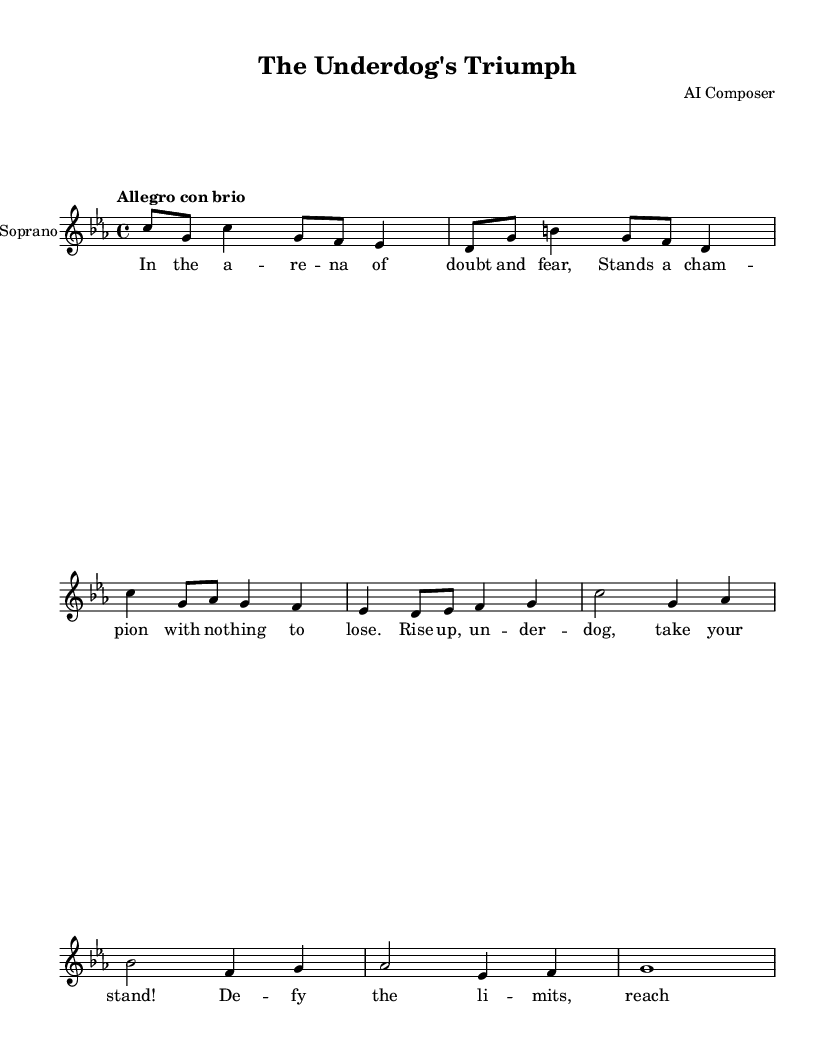What is the key signature of this music? The key signature is indicated at the beginning of the score. In this case, it shows four flats, which indicates that the piece is in C minor.
Answer: C minor What is the time signature of this music? The time signature is located after the key signature at the beginning of the score. It shows '4/4', meaning there are four beats in each measure.
Answer: 4/4 What is the tempo marking of this piece? The tempo marking is written above the music at the start. It states "Allegro con brio", which indicates a lively and brisk tempo.
Answer: Allegro con brio How many measures does the score contain? By counting the vertical lines that indicate the end of each measure, we can find the total number of measures. There are eight measures in this excerpt.
Answer: Eight Which instrument is performing this music? The instrument is specified in the score on the staff label; it indicates "Soprano". This means that the music is intended for the soprano voice.
Answer: Soprano What do the lyrics convey in this opera piece? The lyrics, provided in the 'lyricmode' section of the code, suggest themes of overcoming doubt and fear, embodying the spirit of an underdog champion who rises against all odds.
Answer: Overcoming fear 